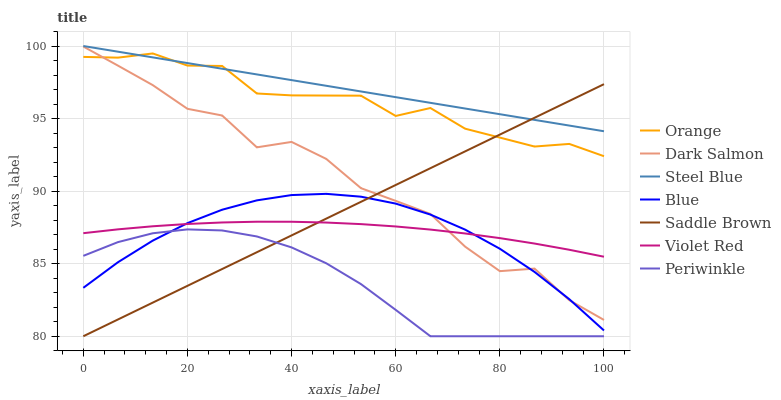Does Violet Red have the minimum area under the curve?
Answer yes or no. No. Does Violet Red have the maximum area under the curve?
Answer yes or no. No. Is Violet Red the smoothest?
Answer yes or no. No. Is Violet Red the roughest?
Answer yes or no. No. Does Violet Red have the lowest value?
Answer yes or no. No. Does Violet Red have the highest value?
Answer yes or no. No. Is Violet Red less than Orange?
Answer yes or no. Yes. Is Steel Blue greater than Blue?
Answer yes or no. Yes. Does Violet Red intersect Orange?
Answer yes or no. No. 